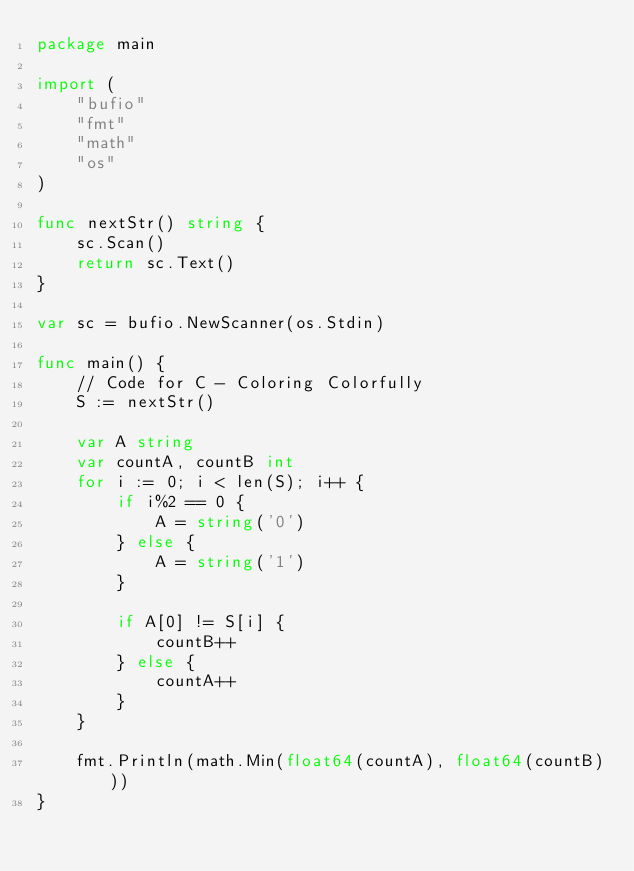<code> <loc_0><loc_0><loc_500><loc_500><_Go_>package main

import (
	"bufio"
	"fmt"
	"math"
	"os"
)

func nextStr() string {
	sc.Scan()
	return sc.Text()
}

var sc = bufio.NewScanner(os.Stdin)

func main() {
	// Code for C - Coloring Colorfully
	S := nextStr()

	var A string
	var countA, countB int
	for i := 0; i < len(S); i++ {
		if i%2 == 0 {
			A = string('0')
		} else {
			A = string('1')
		}

		if A[0] != S[i] {
			countB++
		} else {
			countA++
		}
	}

	fmt.Println(math.Min(float64(countA), float64(countB)))
}
</code> 